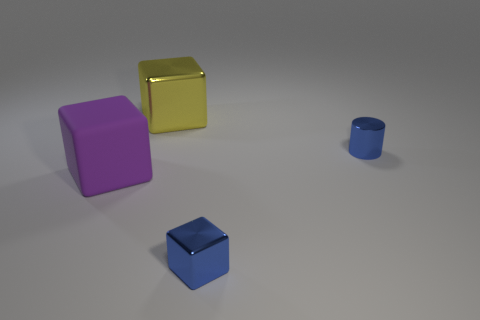Subtract all small blocks. How many blocks are left? 2 Add 3 tiny purple cubes. How many objects exist? 7 Subtract all yellow cubes. How many cubes are left? 2 Subtract all cylinders. How many objects are left? 3 Add 1 large shiny things. How many large shiny things are left? 2 Add 3 blue blocks. How many blue blocks exist? 4 Subtract 0 purple spheres. How many objects are left? 4 Subtract all green cubes. Subtract all red cylinders. How many cubes are left? 3 Subtract all blue cylinders. How many yellow blocks are left? 1 Subtract all purple objects. Subtract all blue things. How many objects are left? 1 